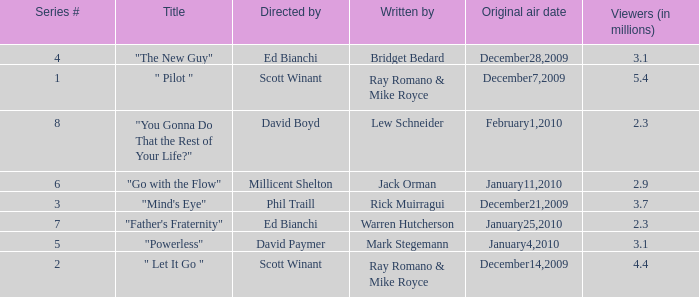How many episodes are written by Lew Schneider? 1.0. 